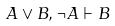<formula> <loc_0><loc_0><loc_500><loc_500>A \vee B , \neg A \vdash B</formula> 